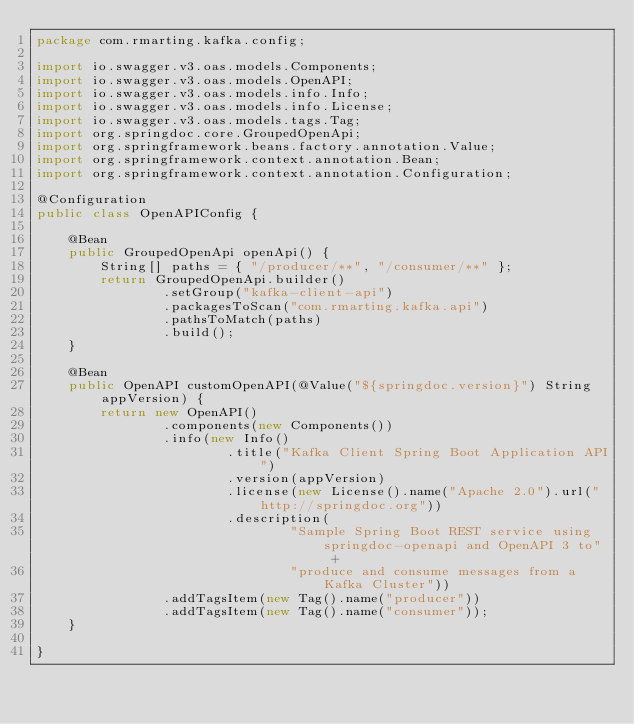Convert code to text. <code><loc_0><loc_0><loc_500><loc_500><_Java_>package com.rmarting.kafka.config;

import io.swagger.v3.oas.models.Components;
import io.swagger.v3.oas.models.OpenAPI;
import io.swagger.v3.oas.models.info.Info;
import io.swagger.v3.oas.models.info.License;
import io.swagger.v3.oas.models.tags.Tag;
import org.springdoc.core.GroupedOpenApi;
import org.springframework.beans.factory.annotation.Value;
import org.springframework.context.annotation.Bean;
import org.springframework.context.annotation.Configuration;

@Configuration
public class OpenAPIConfig {

    @Bean
    public GroupedOpenApi openApi() {
        String[] paths = { "/producer/**", "/consumer/**" };
        return GroupedOpenApi.builder()
                .setGroup("kafka-client-api")
                .packagesToScan("com.rmarting.kafka.api")
                .pathsToMatch(paths)
                .build();
    }

    @Bean
    public OpenAPI customOpenAPI(@Value("${springdoc.version}") String appVersion) {
        return new OpenAPI()
                .components(new Components())
                .info(new Info()
                        .title("Kafka Client Spring Boot Application API")
                        .version(appVersion)
                        .license(new License().name("Apache 2.0").url("http://springdoc.org"))
                        .description(
                                "Sample Spring Boot REST service using springdoc-openapi and OpenAPI 3 to" +
                                "produce and consume messages from a Kafka Cluster"))
                .addTagsItem(new Tag().name("producer"))
                .addTagsItem(new Tag().name("consumer"));
    }

}
</code> 